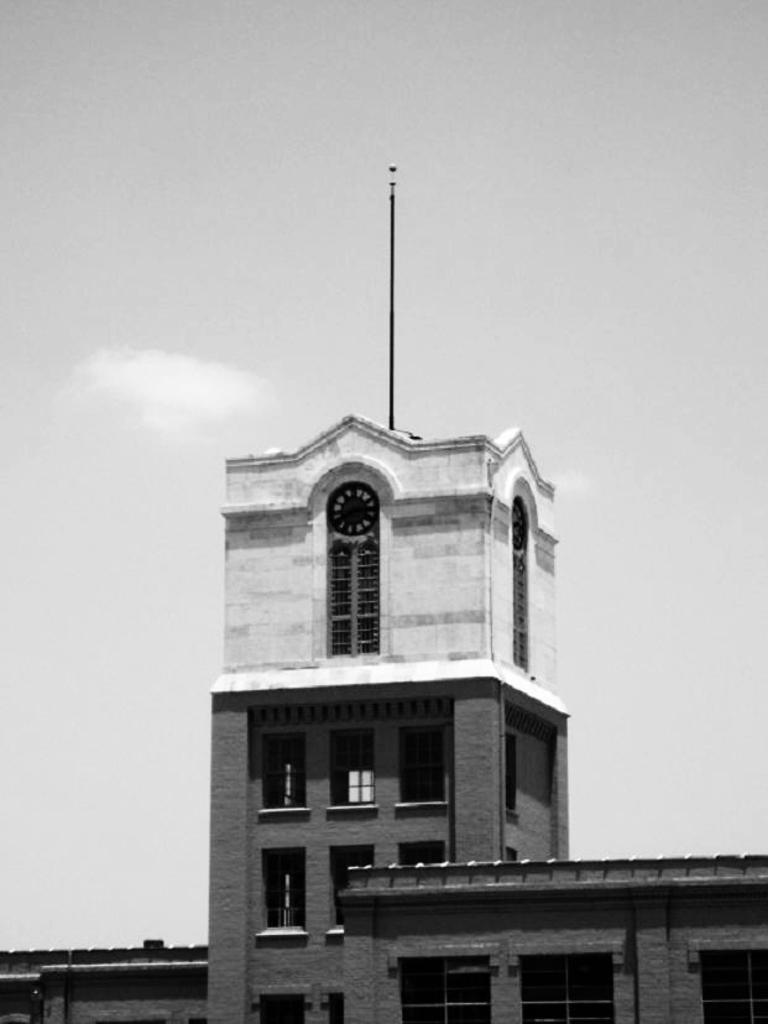What is the main structure in the image? There is a building in the image. What feature can be seen on the building? The building has windows. What other object is present in the image? There is a pole in the image. What part of the natural environment is visible in the image? The sky is visible in the image. What is the writer's opinion on the building in the image? There is no writer or opinion present in the image; it is a photograph of a building, pole, and sky. 